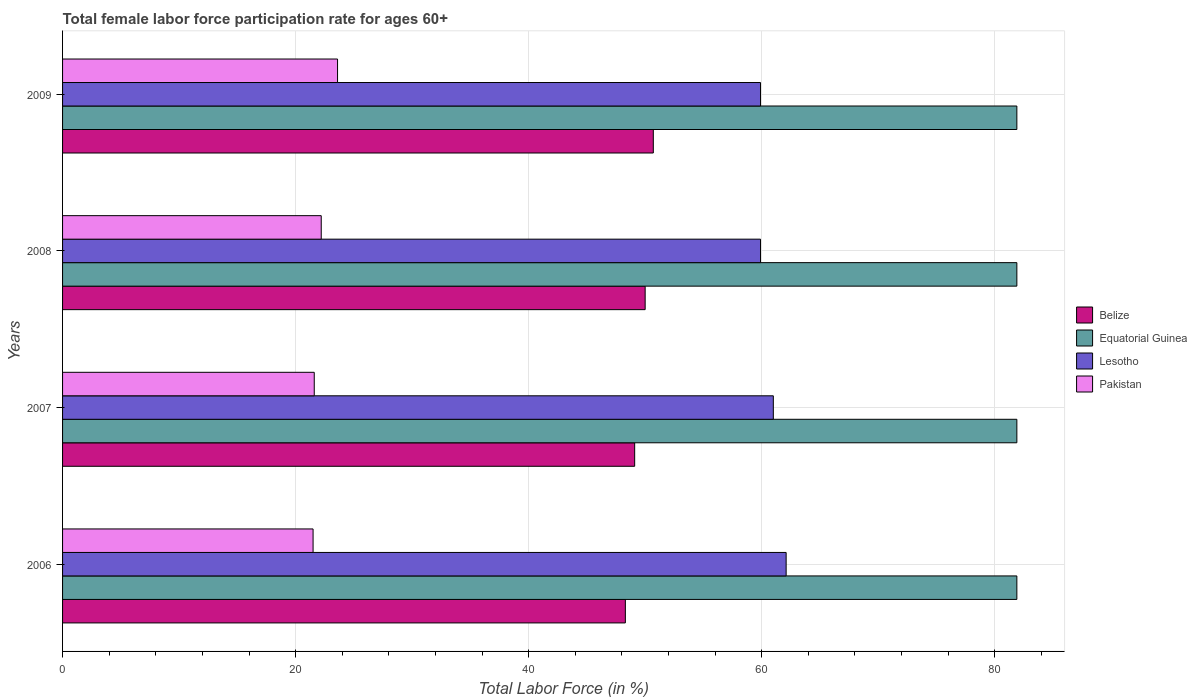How many groups of bars are there?
Your answer should be compact. 4. Are the number of bars per tick equal to the number of legend labels?
Keep it short and to the point. Yes. Are the number of bars on each tick of the Y-axis equal?
Ensure brevity in your answer.  Yes. How many bars are there on the 1st tick from the top?
Keep it short and to the point. 4. How many bars are there on the 4th tick from the bottom?
Your answer should be compact. 4. What is the female labor force participation rate in Equatorial Guinea in 2008?
Give a very brief answer. 81.9. Across all years, what is the maximum female labor force participation rate in Belize?
Provide a short and direct response. 50.7. What is the total female labor force participation rate in Lesotho in the graph?
Provide a succinct answer. 242.9. What is the difference between the female labor force participation rate in Lesotho in 2009 and the female labor force participation rate in Equatorial Guinea in 2008?
Give a very brief answer. -22. What is the average female labor force participation rate in Pakistan per year?
Offer a very short reply. 22.23. In the year 2008, what is the difference between the female labor force participation rate in Belize and female labor force participation rate in Equatorial Guinea?
Offer a very short reply. -31.9. In how many years, is the female labor force participation rate in Belize greater than 68 %?
Make the answer very short. 0. What is the ratio of the female labor force participation rate in Belize in 2007 to that in 2008?
Provide a short and direct response. 0.98. What is the difference between the highest and the second highest female labor force participation rate in Lesotho?
Your response must be concise. 1.1. What is the difference between the highest and the lowest female labor force participation rate in Belize?
Offer a terse response. 2.4. In how many years, is the female labor force participation rate in Lesotho greater than the average female labor force participation rate in Lesotho taken over all years?
Provide a succinct answer. 2. Is it the case that in every year, the sum of the female labor force participation rate in Belize and female labor force participation rate in Pakistan is greater than the sum of female labor force participation rate in Lesotho and female labor force participation rate in Equatorial Guinea?
Keep it short and to the point. No. What does the 4th bar from the top in 2009 represents?
Provide a short and direct response. Belize. What does the 2nd bar from the bottom in 2008 represents?
Keep it short and to the point. Equatorial Guinea. Is it the case that in every year, the sum of the female labor force participation rate in Pakistan and female labor force participation rate in Equatorial Guinea is greater than the female labor force participation rate in Lesotho?
Your answer should be compact. Yes. How many bars are there?
Ensure brevity in your answer.  16. Are all the bars in the graph horizontal?
Ensure brevity in your answer.  Yes. How many legend labels are there?
Provide a short and direct response. 4. How are the legend labels stacked?
Make the answer very short. Vertical. What is the title of the graph?
Offer a terse response. Total female labor force participation rate for ages 60+. Does "Antigua and Barbuda" appear as one of the legend labels in the graph?
Provide a succinct answer. No. What is the label or title of the Y-axis?
Keep it short and to the point. Years. What is the Total Labor Force (in %) in Belize in 2006?
Give a very brief answer. 48.3. What is the Total Labor Force (in %) of Equatorial Guinea in 2006?
Your answer should be compact. 81.9. What is the Total Labor Force (in %) of Lesotho in 2006?
Your answer should be compact. 62.1. What is the Total Labor Force (in %) in Pakistan in 2006?
Your answer should be compact. 21.5. What is the Total Labor Force (in %) in Belize in 2007?
Your answer should be compact. 49.1. What is the Total Labor Force (in %) in Equatorial Guinea in 2007?
Offer a terse response. 81.9. What is the Total Labor Force (in %) of Pakistan in 2007?
Provide a short and direct response. 21.6. What is the Total Labor Force (in %) in Equatorial Guinea in 2008?
Provide a short and direct response. 81.9. What is the Total Labor Force (in %) in Lesotho in 2008?
Your answer should be very brief. 59.9. What is the Total Labor Force (in %) in Pakistan in 2008?
Your response must be concise. 22.2. What is the Total Labor Force (in %) in Belize in 2009?
Your answer should be very brief. 50.7. What is the Total Labor Force (in %) in Equatorial Guinea in 2009?
Offer a very short reply. 81.9. What is the Total Labor Force (in %) of Lesotho in 2009?
Offer a very short reply. 59.9. What is the Total Labor Force (in %) in Pakistan in 2009?
Keep it short and to the point. 23.6. Across all years, what is the maximum Total Labor Force (in %) of Belize?
Your answer should be compact. 50.7. Across all years, what is the maximum Total Labor Force (in %) of Equatorial Guinea?
Your answer should be very brief. 81.9. Across all years, what is the maximum Total Labor Force (in %) of Lesotho?
Give a very brief answer. 62.1. Across all years, what is the maximum Total Labor Force (in %) in Pakistan?
Your answer should be very brief. 23.6. Across all years, what is the minimum Total Labor Force (in %) in Belize?
Your response must be concise. 48.3. Across all years, what is the minimum Total Labor Force (in %) of Equatorial Guinea?
Offer a very short reply. 81.9. Across all years, what is the minimum Total Labor Force (in %) of Lesotho?
Make the answer very short. 59.9. What is the total Total Labor Force (in %) of Belize in the graph?
Make the answer very short. 198.1. What is the total Total Labor Force (in %) of Equatorial Guinea in the graph?
Offer a very short reply. 327.6. What is the total Total Labor Force (in %) in Lesotho in the graph?
Ensure brevity in your answer.  242.9. What is the total Total Labor Force (in %) of Pakistan in the graph?
Provide a short and direct response. 88.9. What is the difference between the Total Labor Force (in %) in Equatorial Guinea in 2006 and that in 2007?
Provide a short and direct response. 0. What is the difference between the Total Labor Force (in %) of Lesotho in 2006 and that in 2007?
Give a very brief answer. 1.1. What is the difference between the Total Labor Force (in %) in Lesotho in 2006 and that in 2008?
Offer a very short reply. 2.2. What is the difference between the Total Labor Force (in %) of Pakistan in 2006 and that in 2008?
Provide a short and direct response. -0.7. What is the difference between the Total Labor Force (in %) in Belize in 2006 and that in 2009?
Keep it short and to the point. -2.4. What is the difference between the Total Labor Force (in %) of Equatorial Guinea in 2006 and that in 2009?
Your answer should be compact. 0. What is the difference between the Total Labor Force (in %) in Lesotho in 2006 and that in 2009?
Ensure brevity in your answer.  2.2. What is the difference between the Total Labor Force (in %) in Belize in 2007 and that in 2008?
Give a very brief answer. -0.9. What is the difference between the Total Labor Force (in %) of Equatorial Guinea in 2007 and that in 2008?
Make the answer very short. 0. What is the difference between the Total Labor Force (in %) in Lesotho in 2007 and that in 2008?
Your answer should be compact. 1.1. What is the difference between the Total Labor Force (in %) in Belize in 2007 and that in 2009?
Offer a very short reply. -1.6. What is the difference between the Total Labor Force (in %) in Lesotho in 2007 and that in 2009?
Make the answer very short. 1.1. What is the difference between the Total Labor Force (in %) of Pakistan in 2007 and that in 2009?
Make the answer very short. -2. What is the difference between the Total Labor Force (in %) of Equatorial Guinea in 2008 and that in 2009?
Make the answer very short. 0. What is the difference between the Total Labor Force (in %) in Belize in 2006 and the Total Labor Force (in %) in Equatorial Guinea in 2007?
Keep it short and to the point. -33.6. What is the difference between the Total Labor Force (in %) in Belize in 2006 and the Total Labor Force (in %) in Pakistan in 2007?
Offer a very short reply. 26.7. What is the difference between the Total Labor Force (in %) in Equatorial Guinea in 2006 and the Total Labor Force (in %) in Lesotho in 2007?
Your answer should be compact. 20.9. What is the difference between the Total Labor Force (in %) of Equatorial Guinea in 2006 and the Total Labor Force (in %) of Pakistan in 2007?
Provide a succinct answer. 60.3. What is the difference between the Total Labor Force (in %) in Lesotho in 2006 and the Total Labor Force (in %) in Pakistan in 2007?
Your answer should be very brief. 40.5. What is the difference between the Total Labor Force (in %) in Belize in 2006 and the Total Labor Force (in %) in Equatorial Guinea in 2008?
Your answer should be compact. -33.6. What is the difference between the Total Labor Force (in %) of Belize in 2006 and the Total Labor Force (in %) of Pakistan in 2008?
Make the answer very short. 26.1. What is the difference between the Total Labor Force (in %) of Equatorial Guinea in 2006 and the Total Labor Force (in %) of Pakistan in 2008?
Offer a terse response. 59.7. What is the difference between the Total Labor Force (in %) of Lesotho in 2006 and the Total Labor Force (in %) of Pakistan in 2008?
Keep it short and to the point. 39.9. What is the difference between the Total Labor Force (in %) of Belize in 2006 and the Total Labor Force (in %) of Equatorial Guinea in 2009?
Give a very brief answer. -33.6. What is the difference between the Total Labor Force (in %) of Belize in 2006 and the Total Labor Force (in %) of Pakistan in 2009?
Offer a terse response. 24.7. What is the difference between the Total Labor Force (in %) in Equatorial Guinea in 2006 and the Total Labor Force (in %) in Lesotho in 2009?
Your answer should be compact. 22. What is the difference between the Total Labor Force (in %) of Equatorial Guinea in 2006 and the Total Labor Force (in %) of Pakistan in 2009?
Your answer should be very brief. 58.3. What is the difference between the Total Labor Force (in %) in Lesotho in 2006 and the Total Labor Force (in %) in Pakistan in 2009?
Provide a short and direct response. 38.5. What is the difference between the Total Labor Force (in %) of Belize in 2007 and the Total Labor Force (in %) of Equatorial Guinea in 2008?
Offer a terse response. -32.8. What is the difference between the Total Labor Force (in %) in Belize in 2007 and the Total Labor Force (in %) in Lesotho in 2008?
Offer a very short reply. -10.8. What is the difference between the Total Labor Force (in %) in Belize in 2007 and the Total Labor Force (in %) in Pakistan in 2008?
Offer a very short reply. 26.9. What is the difference between the Total Labor Force (in %) of Equatorial Guinea in 2007 and the Total Labor Force (in %) of Pakistan in 2008?
Provide a short and direct response. 59.7. What is the difference between the Total Labor Force (in %) of Lesotho in 2007 and the Total Labor Force (in %) of Pakistan in 2008?
Your answer should be very brief. 38.8. What is the difference between the Total Labor Force (in %) in Belize in 2007 and the Total Labor Force (in %) in Equatorial Guinea in 2009?
Ensure brevity in your answer.  -32.8. What is the difference between the Total Labor Force (in %) in Belize in 2007 and the Total Labor Force (in %) in Lesotho in 2009?
Your response must be concise. -10.8. What is the difference between the Total Labor Force (in %) in Equatorial Guinea in 2007 and the Total Labor Force (in %) in Pakistan in 2009?
Offer a terse response. 58.3. What is the difference between the Total Labor Force (in %) of Lesotho in 2007 and the Total Labor Force (in %) of Pakistan in 2009?
Provide a succinct answer. 37.4. What is the difference between the Total Labor Force (in %) in Belize in 2008 and the Total Labor Force (in %) in Equatorial Guinea in 2009?
Your answer should be very brief. -31.9. What is the difference between the Total Labor Force (in %) of Belize in 2008 and the Total Labor Force (in %) of Pakistan in 2009?
Your response must be concise. 26.4. What is the difference between the Total Labor Force (in %) of Equatorial Guinea in 2008 and the Total Labor Force (in %) of Lesotho in 2009?
Your answer should be very brief. 22. What is the difference between the Total Labor Force (in %) in Equatorial Guinea in 2008 and the Total Labor Force (in %) in Pakistan in 2009?
Keep it short and to the point. 58.3. What is the difference between the Total Labor Force (in %) of Lesotho in 2008 and the Total Labor Force (in %) of Pakistan in 2009?
Give a very brief answer. 36.3. What is the average Total Labor Force (in %) in Belize per year?
Your response must be concise. 49.52. What is the average Total Labor Force (in %) of Equatorial Guinea per year?
Give a very brief answer. 81.9. What is the average Total Labor Force (in %) of Lesotho per year?
Provide a succinct answer. 60.73. What is the average Total Labor Force (in %) in Pakistan per year?
Make the answer very short. 22.23. In the year 2006, what is the difference between the Total Labor Force (in %) in Belize and Total Labor Force (in %) in Equatorial Guinea?
Keep it short and to the point. -33.6. In the year 2006, what is the difference between the Total Labor Force (in %) of Belize and Total Labor Force (in %) of Pakistan?
Your answer should be compact. 26.8. In the year 2006, what is the difference between the Total Labor Force (in %) in Equatorial Guinea and Total Labor Force (in %) in Lesotho?
Your answer should be compact. 19.8. In the year 2006, what is the difference between the Total Labor Force (in %) in Equatorial Guinea and Total Labor Force (in %) in Pakistan?
Offer a terse response. 60.4. In the year 2006, what is the difference between the Total Labor Force (in %) in Lesotho and Total Labor Force (in %) in Pakistan?
Provide a short and direct response. 40.6. In the year 2007, what is the difference between the Total Labor Force (in %) in Belize and Total Labor Force (in %) in Equatorial Guinea?
Keep it short and to the point. -32.8. In the year 2007, what is the difference between the Total Labor Force (in %) of Belize and Total Labor Force (in %) of Pakistan?
Your response must be concise. 27.5. In the year 2007, what is the difference between the Total Labor Force (in %) in Equatorial Guinea and Total Labor Force (in %) in Lesotho?
Provide a succinct answer. 20.9. In the year 2007, what is the difference between the Total Labor Force (in %) of Equatorial Guinea and Total Labor Force (in %) of Pakistan?
Ensure brevity in your answer.  60.3. In the year 2007, what is the difference between the Total Labor Force (in %) in Lesotho and Total Labor Force (in %) in Pakistan?
Give a very brief answer. 39.4. In the year 2008, what is the difference between the Total Labor Force (in %) in Belize and Total Labor Force (in %) in Equatorial Guinea?
Your answer should be compact. -31.9. In the year 2008, what is the difference between the Total Labor Force (in %) of Belize and Total Labor Force (in %) of Lesotho?
Offer a terse response. -9.9. In the year 2008, what is the difference between the Total Labor Force (in %) of Belize and Total Labor Force (in %) of Pakistan?
Ensure brevity in your answer.  27.8. In the year 2008, what is the difference between the Total Labor Force (in %) in Equatorial Guinea and Total Labor Force (in %) in Pakistan?
Offer a terse response. 59.7. In the year 2008, what is the difference between the Total Labor Force (in %) of Lesotho and Total Labor Force (in %) of Pakistan?
Give a very brief answer. 37.7. In the year 2009, what is the difference between the Total Labor Force (in %) of Belize and Total Labor Force (in %) of Equatorial Guinea?
Ensure brevity in your answer.  -31.2. In the year 2009, what is the difference between the Total Labor Force (in %) of Belize and Total Labor Force (in %) of Lesotho?
Offer a terse response. -9.2. In the year 2009, what is the difference between the Total Labor Force (in %) of Belize and Total Labor Force (in %) of Pakistan?
Your answer should be very brief. 27.1. In the year 2009, what is the difference between the Total Labor Force (in %) in Equatorial Guinea and Total Labor Force (in %) in Pakistan?
Keep it short and to the point. 58.3. In the year 2009, what is the difference between the Total Labor Force (in %) of Lesotho and Total Labor Force (in %) of Pakistan?
Offer a terse response. 36.3. What is the ratio of the Total Labor Force (in %) in Belize in 2006 to that in 2007?
Ensure brevity in your answer.  0.98. What is the ratio of the Total Labor Force (in %) in Pakistan in 2006 to that in 2007?
Provide a succinct answer. 1. What is the ratio of the Total Labor Force (in %) in Lesotho in 2006 to that in 2008?
Your response must be concise. 1.04. What is the ratio of the Total Labor Force (in %) in Pakistan in 2006 to that in 2008?
Give a very brief answer. 0.97. What is the ratio of the Total Labor Force (in %) in Belize in 2006 to that in 2009?
Offer a very short reply. 0.95. What is the ratio of the Total Labor Force (in %) in Lesotho in 2006 to that in 2009?
Offer a terse response. 1.04. What is the ratio of the Total Labor Force (in %) of Pakistan in 2006 to that in 2009?
Offer a very short reply. 0.91. What is the ratio of the Total Labor Force (in %) in Belize in 2007 to that in 2008?
Offer a terse response. 0.98. What is the ratio of the Total Labor Force (in %) in Equatorial Guinea in 2007 to that in 2008?
Give a very brief answer. 1. What is the ratio of the Total Labor Force (in %) in Lesotho in 2007 to that in 2008?
Your answer should be very brief. 1.02. What is the ratio of the Total Labor Force (in %) of Belize in 2007 to that in 2009?
Your response must be concise. 0.97. What is the ratio of the Total Labor Force (in %) in Equatorial Guinea in 2007 to that in 2009?
Your response must be concise. 1. What is the ratio of the Total Labor Force (in %) of Lesotho in 2007 to that in 2009?
Keep it short and to the point. 1.02. What is the ratio of the Total Labor Force (in %) in Pakistan in 2007 to that in 2009?
Your answer should be compact. 0.92. What is the ratio of the Total Labor Force (in %) in Belize in 2008 to that in 2009?
Offer a very short reply. 0.99. What is the ratio of the Total Labor Force (in %) in Equatorial Guinea in 2008 to that in 2009?
Keep it short and to the point. 1. What is the ratio of the Total Labor Force (in %) in Pakistan in 2008 to that in 2009?
Provide a succinct answer. 0.94. What is the difference between the highest and the second highest Total Labor Force (in %) in Pakistan?
Make the answer very short. 1.4. What is the difference between the highest and the lowest Total Labor Force (in %) of Equatorial Guinea?
Keep it short and to the point. 0. What is the difference between the highest and the lowest Total Labor Force (in %) of Pakistan?
Ensure brevity in your answer.  2.1. 